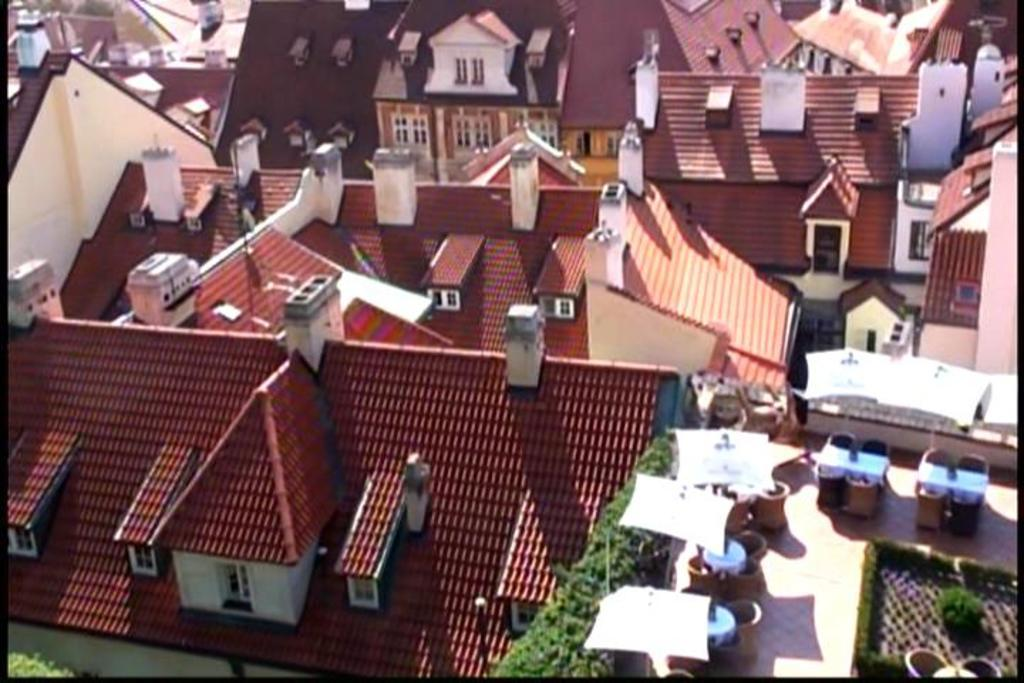What type of structures can be seen in the image? There are buildings in the image. What objects are located on the right side of the image? There are tables and parasols on the right side of the image. What type of vegetation is present in the image? Hedges and bushes are visible in the image. What statement does the hedge make in the image? Hedges do not make statements; they are a type of vegetation that provides a barrier or boundary. 